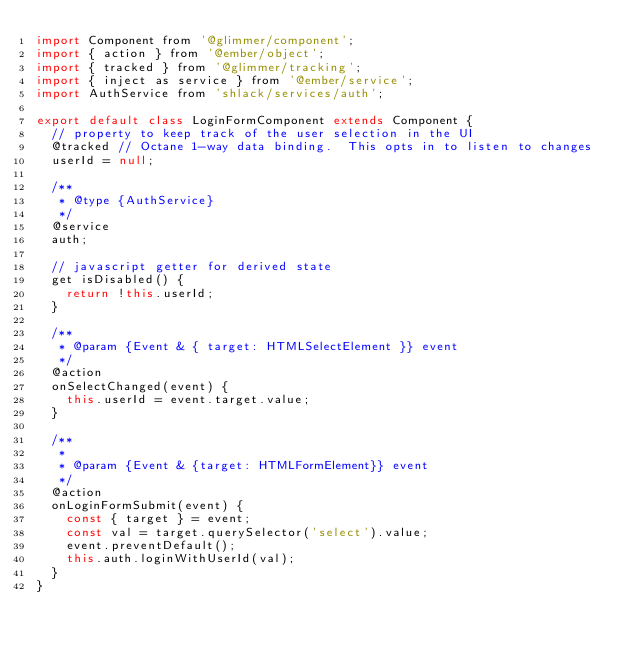Convert code to text. <code><loc_0><loc_0><loc_500><loc_500><_JavaScript_>import Component from '@glimmer/component';
import { action } from '@ember/object';
import { tracked } from '@glimmer/tracking';
import { inject as service } from '@ember/service';
import AuthService from 'shlack/services/auth';

export default class LoginFormComponent extends Component {
  // property to keep track of the user selection in the UI
  @tracked // Octane 1-way data binding.  This opts in to listen to changes
  userId = null;

  /**
   * @type {AuthService}
   */
  @service
  auth;

  // javascript getter for derived state
  get isDisabled() {
    return !this.userId;
  }

  /**
   * @param {Event & { target: HTMLSelectElement }} event
   */
  @action
  onSelectChanged(event) {
    this.userId = event.target.value;
  }

  /**
   *
   * @param {Event & {target: HTMLFormElement}} event
   */
  @action
  onLoginFormSubmit(event) {
    const { target } = event;
    const val = target.querySelector('select').value;
    event.preventDefault();
    this.auth.loginWithUserId(val);
  }
}
</code> 